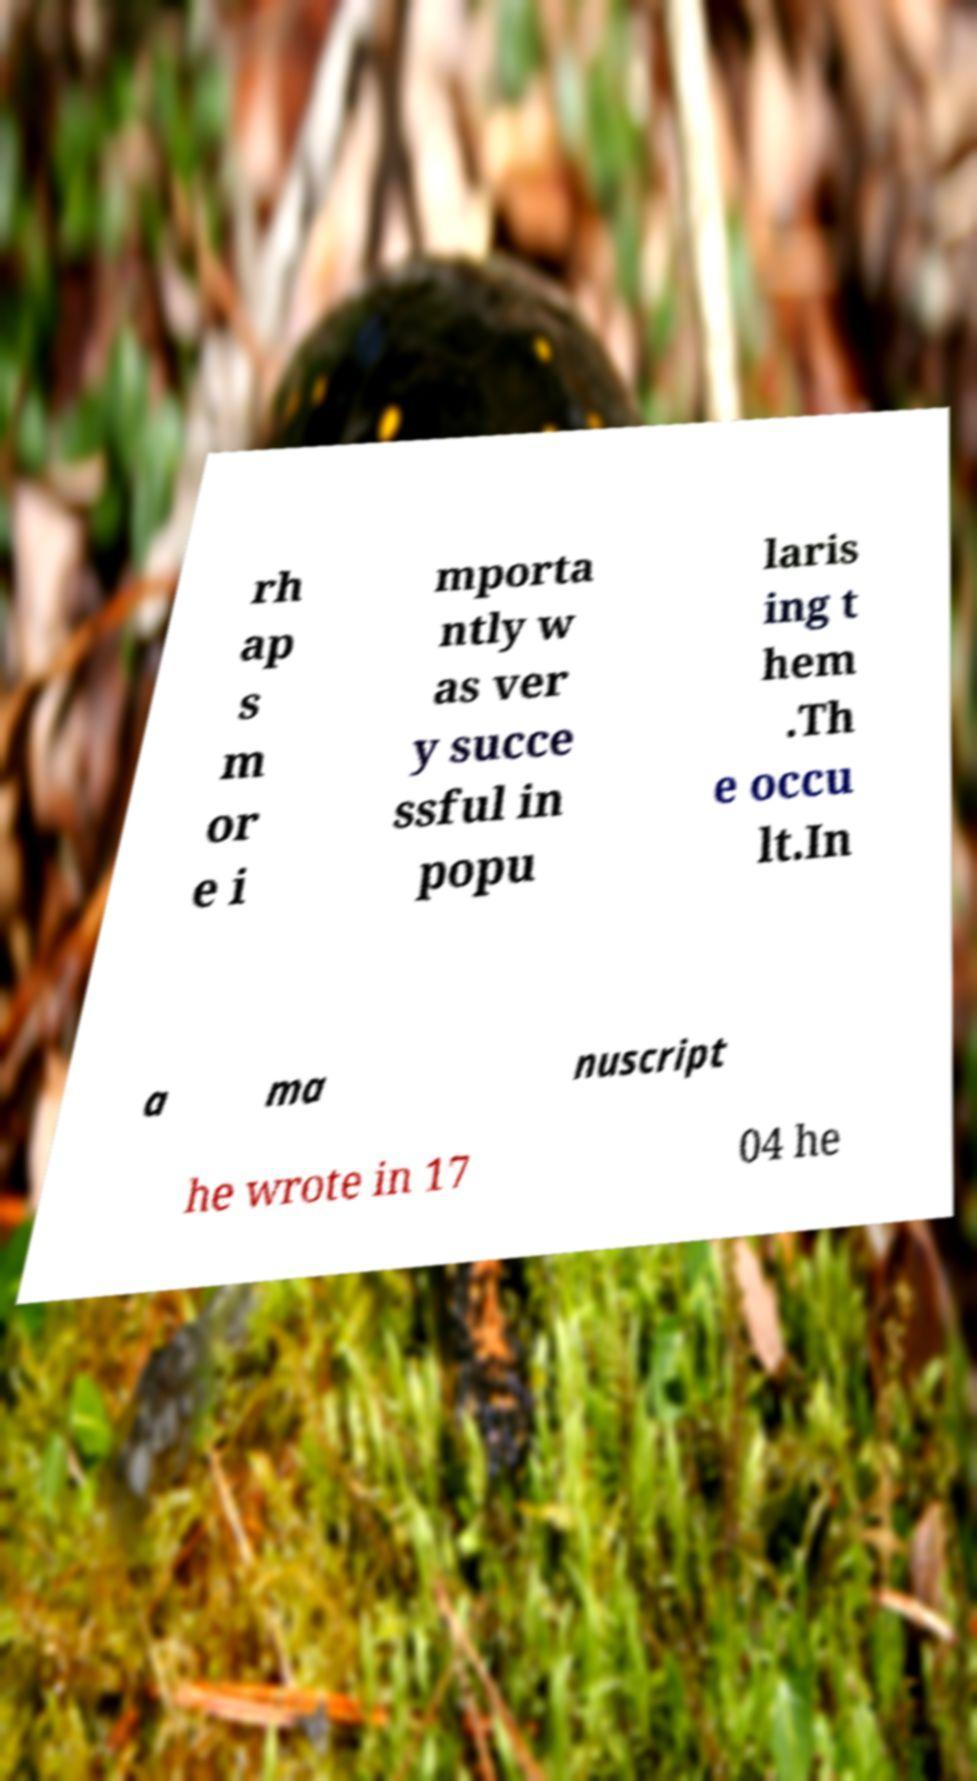Please identify and transcribe the text found in this image. rh ap s m or e i mporta ntly w as ver y succe ssful in popu laris ing t hem .Th e occu lt.In a ma nuscript he wrote in 17 04 he 